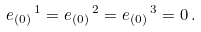<formula> <loc_0><loc_0><loc_500><loc_500>e _ { ( 0 ) } \, ^ { 1 } = e _ { ( 0 ) } \, ^ { 2 } = e _ { ( 0 ) } \, ^ { 3 } = 0 \, .</formula> 